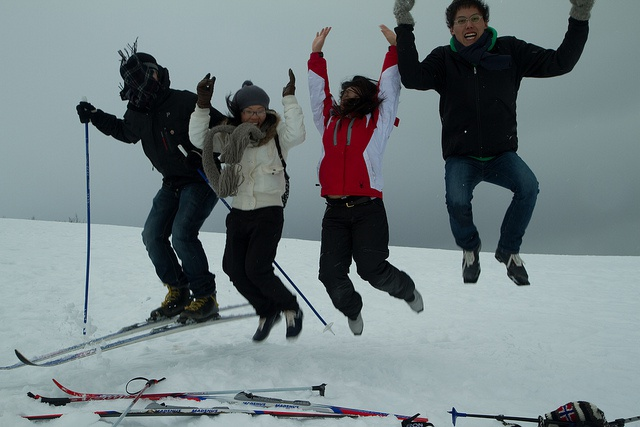Describe the objects in this image and their specific colors. I can see people in darkgray, black, gray, and maroon tones, people in darkgray, black, maroon, and gray tones, people in darkgray, black, gray, and purple tones, people in darkgray, black, and gray tones, and skis in darkgray, maroon, gray, and black tones in this image. 